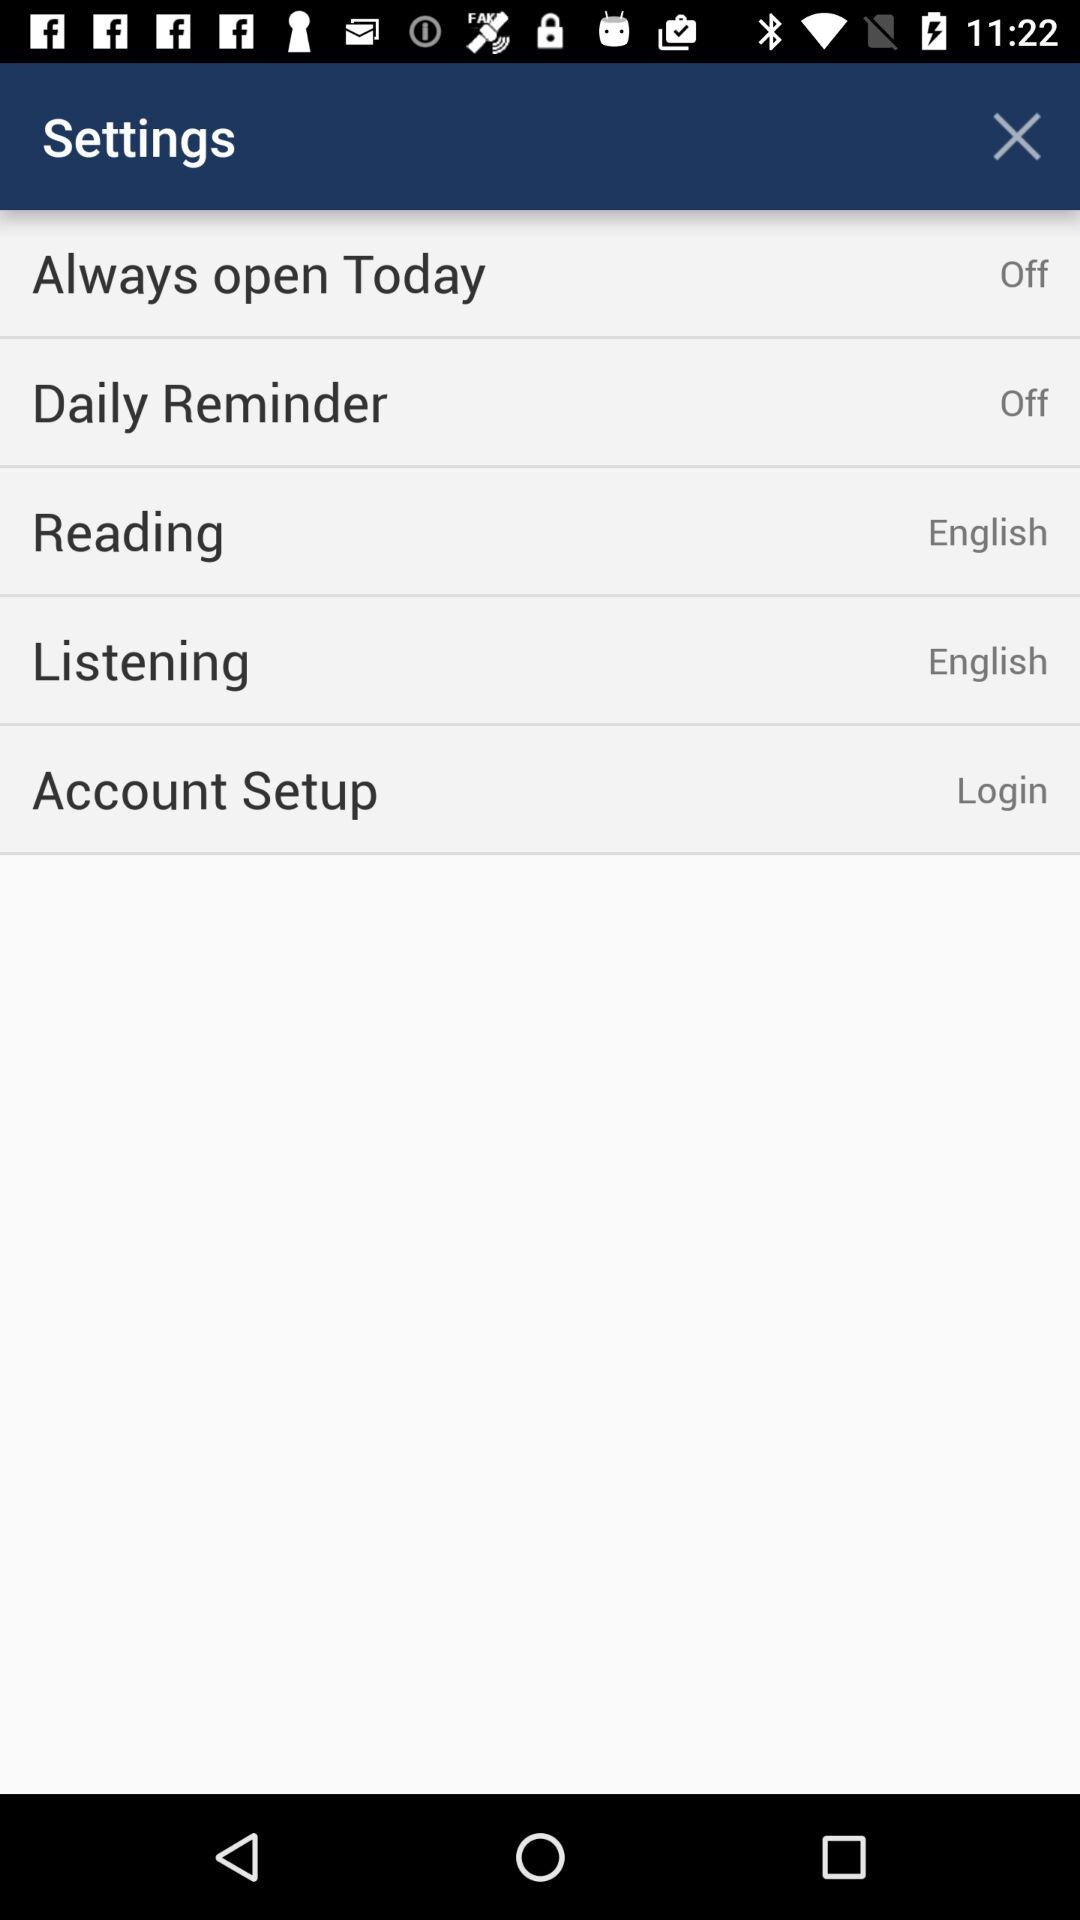What is the selected reading language? The selected reading language is English. 